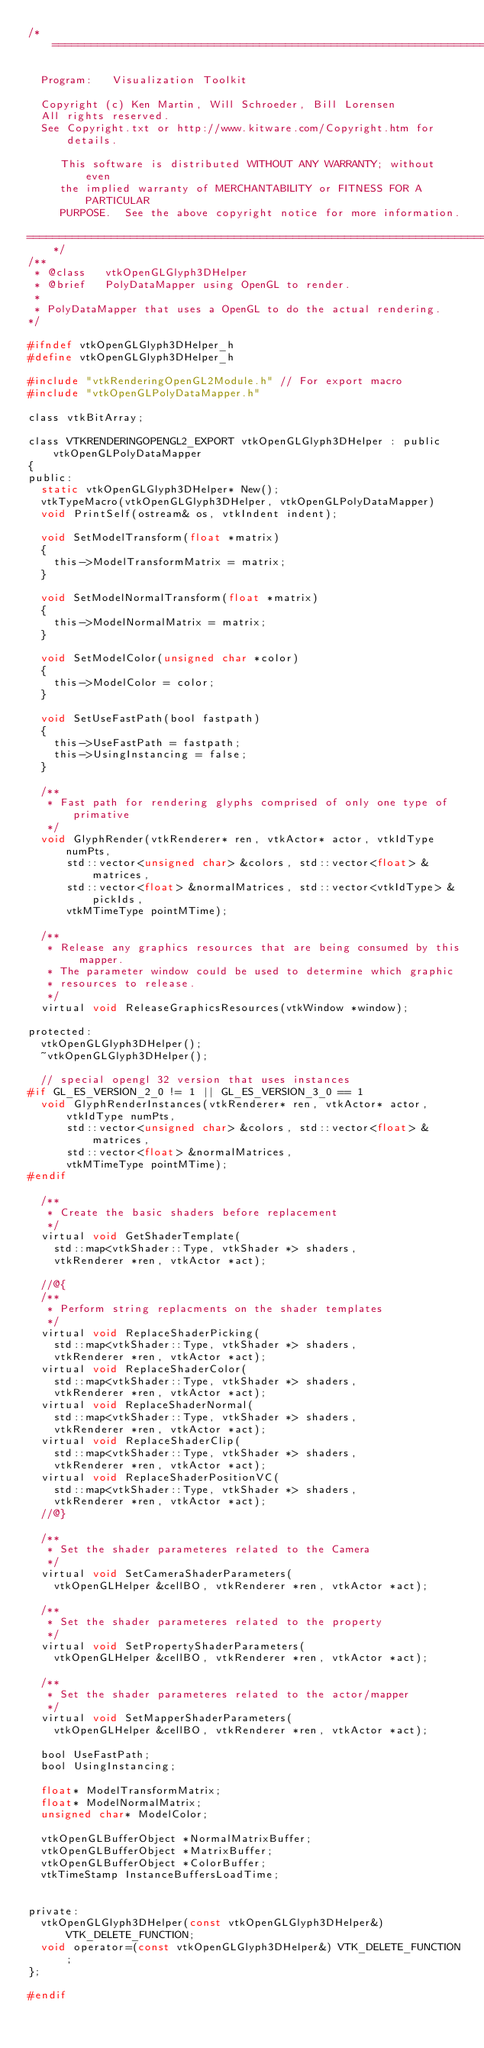Convert code to text. <code><loc_0><loc_0><loc_500><loc_500><_C_>/*=========================================================================

  Program:   Visualization Toolkit

  Copyright (c) Ken Martin, Will Schroeder, Bill Lorensen
  All rights reserved.
  See Copyright.txt or http://www.kitware.com/Copyright.htm for details.

     This software is distributed WITHOUT ANY WARRANTY; without even
     the implied warranty of MERCHANTABILITY or FITNESS FOR A PARTICULAR
     PURPOSE.  See the above copyright notice for more information.

=========================================================================*/
/**
 * @class   vtkOpenGLGlyph3DHelper
 * @brief   PolyDataMapper using OpenGL to render.
 *
 * PolyDataMapper that uses a OpenGL to do the actual rendering.
*/

#ifndef vtkOpenGLGlyph3DHelper_h
#define vtkOpenGLGlyph3DHelper_h

#include "vtkRenderingOpenGL2Module.h" // For export macro
#include "vtkOpenGLPolyDataMapper.h"

class vtkBitArray;

class VTKRENDERINGOPENGL2_EXPORT vtkOpenGLGlyph3DHelper : public vtkOpenGLPolyDataMapper
{
public:
  static vtkOpenGLGlyph3DHelper* New();
  vtkTypeMacro(vtkOpenGLGlyph3DHelper, vtkOpenGLPolyDataMapper)
  void PrintSelf(ostream& os, vtkIndent indent);

  void SetModelTransform(float *matrix)
  {
    this->ModelTransformMatrix = matrix;
  }

  void SetModelNormalTransform(float *matrix)
  {
    this->ModelNormalMatrix = matrix;
  }

  void SetModelColor(unsigned char *color)
  {
    this->ModelColor = color;
  }

  void SetUseFastPath(bool fastpath)
  {
    this->UseFastPath = fastpath;
    this->UsingInstancing = false;
  }

  /**
   * Fast path for rendering glyphs comprised of only one type of primative
   */
  void GlyphRender(vtkRenderer* ren, vtkActor* actor, vtkIdType numPts,
      std::vector<unsigned char> &colors, std::vector<float> &matrices,
      std::vector<float> &normalMatrices, std::vector<vtkIdType> &pickIds,
      vtkMTimeType pointMTime);

  /**
   * Release any graphics resources that are being consumed by this mapper.
   * The parameter window could be used to determine which graphic
   * resources to release.
   */
  virtual void ReleaseGraphicsResources(vtkWindow *window);

protected:
  vtkOpenGLGlyph3DHelper();
  ~vtkOpenGLGlyph3DHelper();

  // special opengl 32 version that uses instances
#if GL_ES_VERSION_2_0 != 1 || GL_ES_VERSION_3_0 == 1
  void GlyphRenderInstances(vtkRenderer* ren, vtkActor* actor, vtkIdType numPts,
      std::vector<unsigned char> &colors, std::vector<float> &matrices,
      std::vector<float> &normalMatrices,
      vtkMTimeType pointMTime);
#endif

  /**
   * Create the basic shaders before replacement
   */
  virtual void GetShaderTemplate(
    std::map<vtkShader::Type, vtkShader *> shaders,
    vtkRenderer *ren, vtkActor *act);

  //@{
  /**
   * Perform string replacments on the shader templates
   */
  virtual void ReplaceShaderPicking(
    std::map<vtkShader::Type, vtkShader *> shaders,
    vtkRenderer *ren, vtkActor *act);
  virtual void ReplaceShaderColor(
    std::map<vtkShader::Type, vtkShader *> shaders,
    vtkRenderer *ren, vtkActor *act);
  virtual void ReplaceShaderNormal(
    std::map<vtkShader::Type, vtkShader *> shaders,
    vtkRenderer *ren, vtkActor *act);
  virtual void ReplaceShaderClip(
    std::map<vtkShader::Type, vtkShader *> shaders,
    vtkRenderer *ren, vtkActor *act);
  virtual void ReplaceShaderPositionVC(
    std::map<vtkShader::Type, vtkShader *> shaders,
    vtkRenderer *ren, vtkActor *act);
  //@}

  /**
   * Set the shader parameteres related to the Camera
   */
  virtual void SetCameraShaderParameters(
    vtkOpenGLHelper &cellBO, vtkRenderer *ren, vtkActor *act);

  /**
   * Set the shader parameteres related to the property
   */
  virtual void SetPropertyShaderParameters(
    vtkOpenGLHelper &cellBO, vtkRenderer *ren, vtkActor *act);

  /**
   * Set the shader parameteres related to the actor/mapper
   */
  virtual void SetMapperShaderParameters(
    vtkOpenGLHelper &cellBO, vtkRenderer *ren, vtkActor *act);

  bool UseFastPath;
  bool UsingInstancing;

  float* ModelTransformMatrix;
  float* ModelNormalMatrix;
  unsigned char* ModelColor;

  vtkOpenGLBufferObject *NormalMatrixBuffer;
  vtkOpenGLBufferObject *MatrixBuffer;
  vtkOpenGLBufferObject *ColorBuffer;
  vtkTimeStamp InstanceBuffersLoadTime;


private:
  vtkOpenGLGlyph3DHelper(const vtkOpenGLGlyph3DHelper&) VTK_DELETE_FUNCTION;
  void operator=(const vtkOpenGLGlyph3DHelper&) VTK_DELETE_FUNCTION;
};

#endif
</code> 